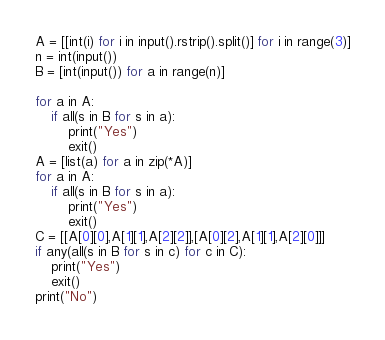Convert code to text. <code><loc_0><loc_0><loc_500><loc_500><_Python_>A = [[int(i) for i in input().rstrip().split()] for i in range(3)]
n = int(input())
B = [int(input()) for a in range(n)]

for a in A:
    if all(s in B for s in a):
        print("Yes")
        exit()
A = [list(a) for a in zip(*A)]
for a in A:
    if all(s in B for s in a):
        print("Yes")
        exit()
C = [[A[0][0],A[1][1],A[2][2]],[A[0][2],A[1][1],A[2][0]]]
if any(all(s in B for s in c) for c in C):
    print("Yes")
    exit()
print("No")</code> 